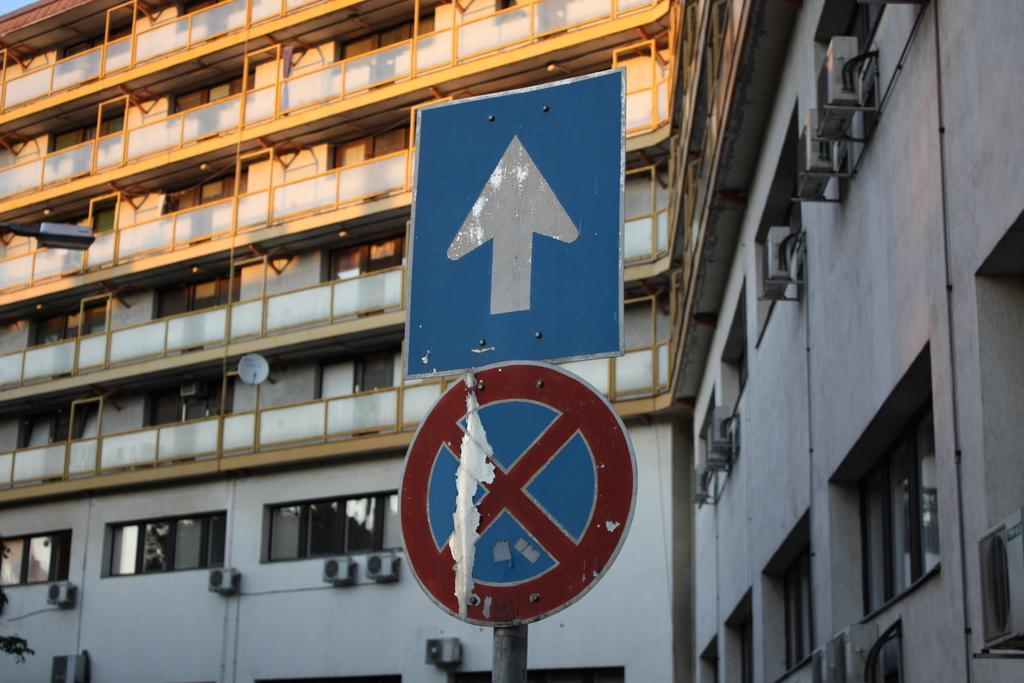What type of objects can be seen in the image? There are sign boards and a street light in the image. What can be seen in the background of the image? There is a building and windows visible in the background of the image. Can you describe any additional features in the image? There is an antenna in the image. What type of quince is being sold at the store in the image? There is no store or quince present in the image; it features sign boards, a street light, a building, windows, and an antenna. What channel can be seen on the television in the image? There is no television present in the image. 